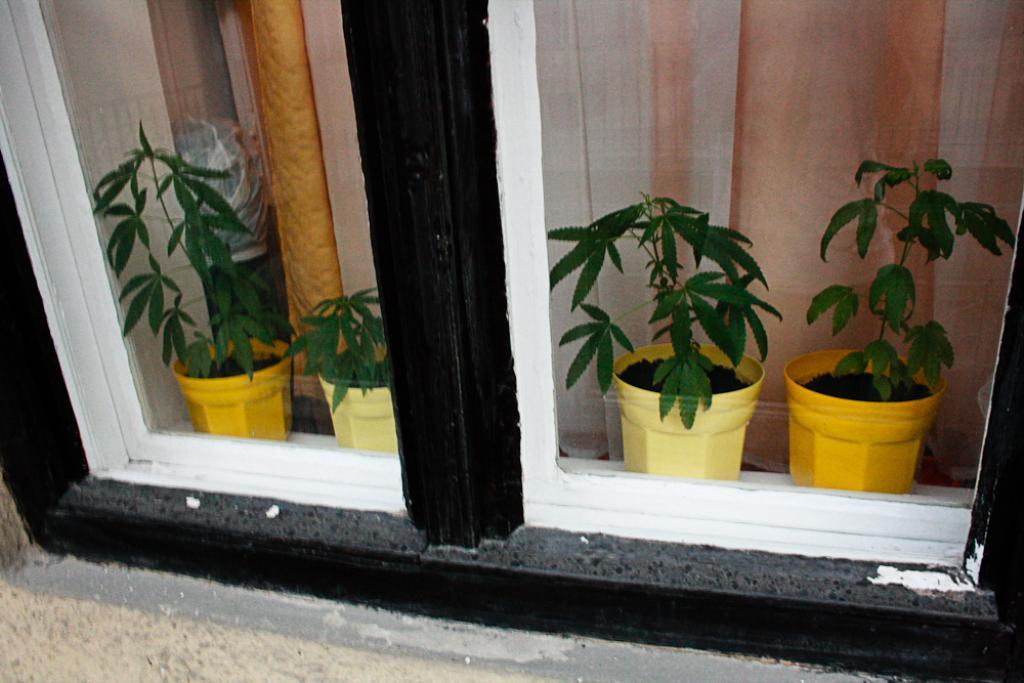What type of structure is present in the image? There is a glass window in the image. What can be seen through the window? Plants are visible behind the window. What type of window treatment is present in the image? There is a curtain in the image. Can you see your brother jumping over corn in the image? There is no brother, jumping, or corn present in the image. 